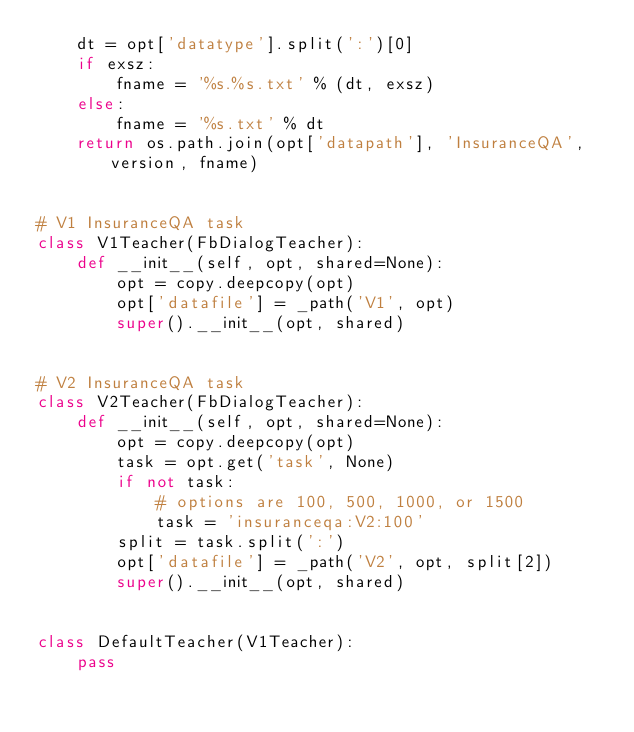Convert code to text. <code><loc_0><loc_0><loc_500><loc_500><_Python_>    dt = opt['datatype'].split(':')[0]
    if exsz:
        fname = '%s.%s.txt' % (dt, exsz)
    else:
        fname = '%s.txt' % dt
    return os.path.join(opt['datapath'], 'InsuranceQA', version, fname)


# V1 InsuranceQA task
class V1Teacher(FbDialogTeacher):
    def __init__(self, opt, shared=None):
        opt = copy.deepcopy(opt)
        opt['datafile'] = _path('V1', opt)
        super().__init__(opt, shared)


# V2 InsuranceQA task
class V2Teacher(FbDialogTeacher):
    def __init__(self, opt, shared=None):
        opt = copy.deepcopy(opt)
        task = opt.get('task', None)
        if not task:
            # options are 100, 500, 1000, or 1500
            task = 'insuranceqa:V2:100'
        split = task.split(':')
        opt['datafile'] = _path('V2', opt, split[2])
        super().__init__(opt, shared)


class DefaultTeacher(V1Teacher):
    pass
</code> 